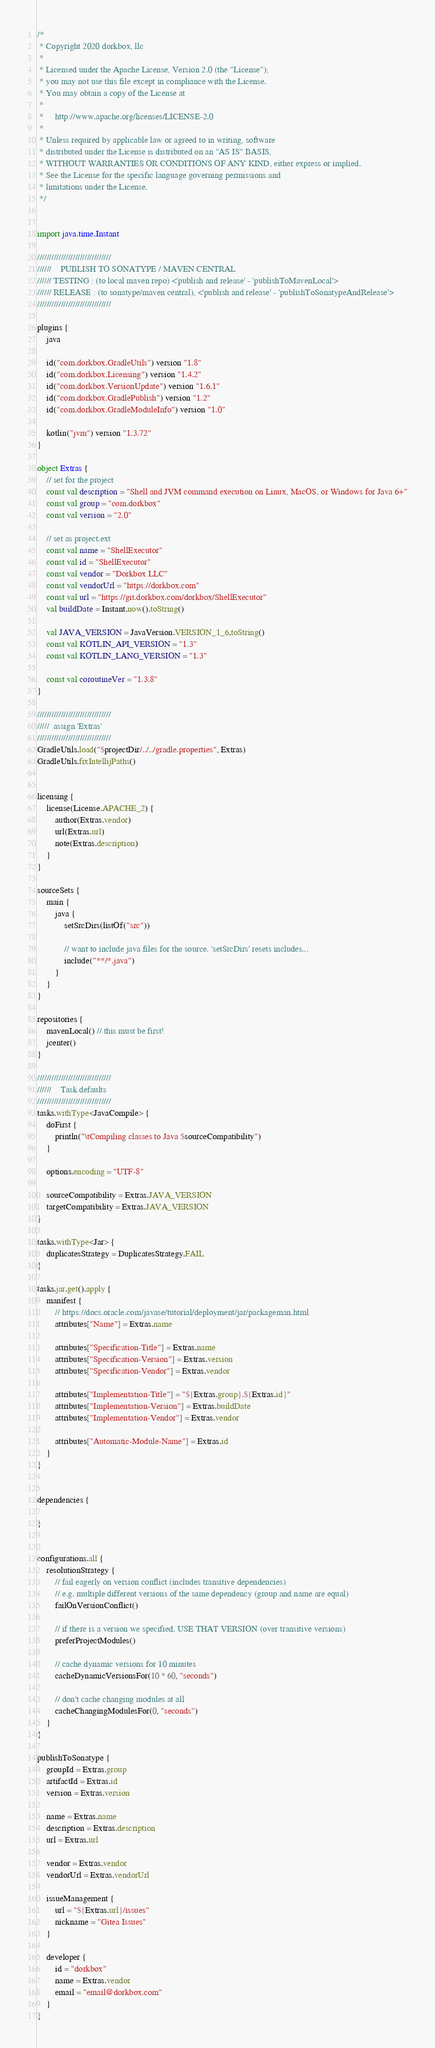<code> <loc_0><loc_0><loc_500><loc_500><_Kotlin_>/*
 * Copyright 2020 dorkbox, llc
 *
 * Licensed under the Apache License, Version 2.0 (the "License");
 * you may not use this file except in compliance with the License.
 * You may obtain a copy of the License at
 *
 *     http://www.apache.org/licenses/LICENSE-2.0
 *
 * Unless required by applicable law or agreed to in writing, software
 * distributed under the License is distributed on an "AS IS" BASIS,
 * WITHOUT WARRANTIES OR CONDITIONS OF ANY KIND, either express or implied.
 * See the License for the specific language governing permissions and
 * limitations under the License.
 */


import java.time.Instant

///////////////////////////////
//////    PUBLISH TO SONATYPE / MAVEN CENTRAL
////// TESTING : (to local maven repo) <'publish and release' - 'publishToMavenLocal'>
////// RELEASE : (to sonatype/maven central), <'publish and release' - 'publishToSonatypeAndRelease'>
///////////////////////////////

plugins {
    java

    id("com.dorkbox.GradleUtils") version "1.8"
    id("com.dorkbox.Licensing") version "1.4.2"
    id("com.dorkbox.VersionUpdate") version "1.6.1"
    id("com.dorkbox.GradlePublish") version "1.2"
    id("com.dorkbox.GradleModuleInfo") version "1.0"

    kotlin("jvm") version "1.3.72"
}

object Extras {
    // set for the project
    const val description = "Shell and JVM command execution on Linux, MacOS, or Windows for Java 6+"
    const val group = "com.dorkbox"
    const val version = "2.0"

    // set as project.ext
    const val name = "ShellExecutor"
    const val id = "ShellExecutor"
    const val vendor = "Dorkbox LLC"
    const val vendorUrl = "https://dorkbox.com"
    const val url = "https://git.dorkbox.com/dorkbox/ShellExecutor"
    val buildDate = Instant.now().toString()

    val JAVA_VERSION = JavaVersion.VERSION_1_6.toString()
    const val KOTLIN_API_VERSION = "1.3"
    const val KOTLIN_LANG_VERSION = "1.3"

    const val coroutineVer = "1.3.8"
}

///////////////////////////////
/////  assign 'Extras'
///////////////////////////////
GradleUtils.load("$projectDir/../../gradle.properties", Extras)
GradleUtils.fixIntellijPaths()


licensing {
    license(License.APACHE_2) {
        author(Extras.vendor)
        url(Extras.url)
        note(Extras.description)
    }
}

sourceSets {
    main {
        java {
            setSrcDirs(listOf("src"))

            // want to include java files for the source. 'setSrcDirs' resets includes...
            include("**/*.java")
        }
    }
}

repositories {
    mavenLocal() // this must be first!
    jcenter()
}

///////////////////////////////
//////    Task defaults
///////////////////////////////
tasks.withType<JavaCompile> {
    doFirst {
        println("\tCompiling classes to Java $sourceCompatibility")
    }

    options.encoding = "UTF-8"

    sourceCompatibility = Extras.JAVA_VERSION
    targetCompatibility = Extras.JAVA_VERSION
}

tasks.withType<Jar> {
    duplicatesStrategy = DuplicatesStrategy.FAIL
}

tasks.jar.get().apply {
    manifest {
        // https://docs.oracle.com/javase/tutorial/deployment/jar/packageman.html
        attributes["Name"] = Extras.name

        attributes["Specification-Title"] = Extras.name
        attributes["Specification-Version"] = Extras.version
        attributes["Specification-Vendor"] = Extras.vendor

        attributes["Implementation-Title"] = "${Extras.group}.${Extras.id}"
        attributes["Implementation-Version"] = Extras.buildDate
        attributes["Implementation-Vendor"] = Extras.vendor

        attributes["Automatic-Module-Name"] = Extras.id
    }
}


dependencies {

}


configurations.all {
    resolutionStrategy {
        // fail eagerly on version conflict (includes transitive dependencies)
        // e.g. multiple different versions of the same dependency (group and name are equal)
        failOnVersionConflict()

        // if there is a version we specified, USE THAT VERSION (over transitive versions)
        preferProjectModules()

        // cache dynamic versions for 10 minutes
        cacheDynamicVersionsFor(10 * 60, "seconds")

        // don't cache changing modules at all
        cacheChangingModulesFor(0, "seconds")
    }
}

publishToSonatype {
    groupId = Extras.group
    artifactId = Extras.id
    version = Extras.version

    name = Extras.name
    description = Extras.description
    url = Extras.url

    vendor = Extras.vendor
    vendorUrl = Extras.vendorUrl

    issueManagement {
        url = "${Extras.url}/issues"
        nickname = "Gitea Issues"
    }

    developer {
        id = "dorkbox"
        name = Extras.vendor
        email = "email@dorkbox.com"
    }
}
</code> 